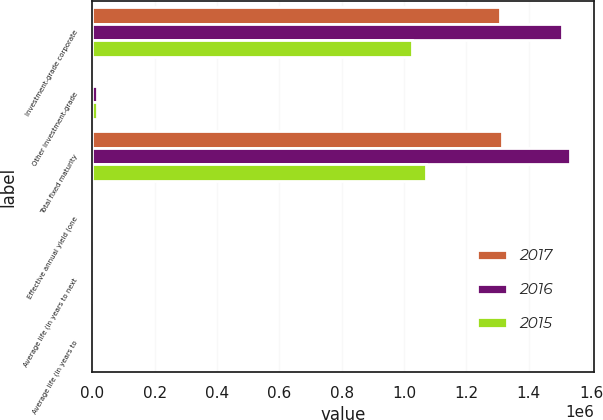<chart> <loc_0><loc_0><loc_500><loc_500><stacked_bar_chart><ecel><fcel>Investment-grade corporate<fcel>Other investment-grade<fcel>Total fixed maturity<fcel>Effective annual yield (one<fcel>Average life (in years to next<fcel>Average life (in years to<nl><fcel>2017<fcel>1.30857e+06<fcel>6042<fcel>1.31461e+06<fcel>4.67<fcel>23<fcel>24<nl><fcel>2016<fcel>1.50514e+06<fcel>14727<fcel>1.53288e+06<fcel>4.67<fcel>24.6<fcel>25.4<nl><fcel>2015<fcel>1.02652e+06<fcel>15296<fcel>1.07091e+06<fcel>4.79<fcel>27.2<fcel>27.9<nl></chart> 